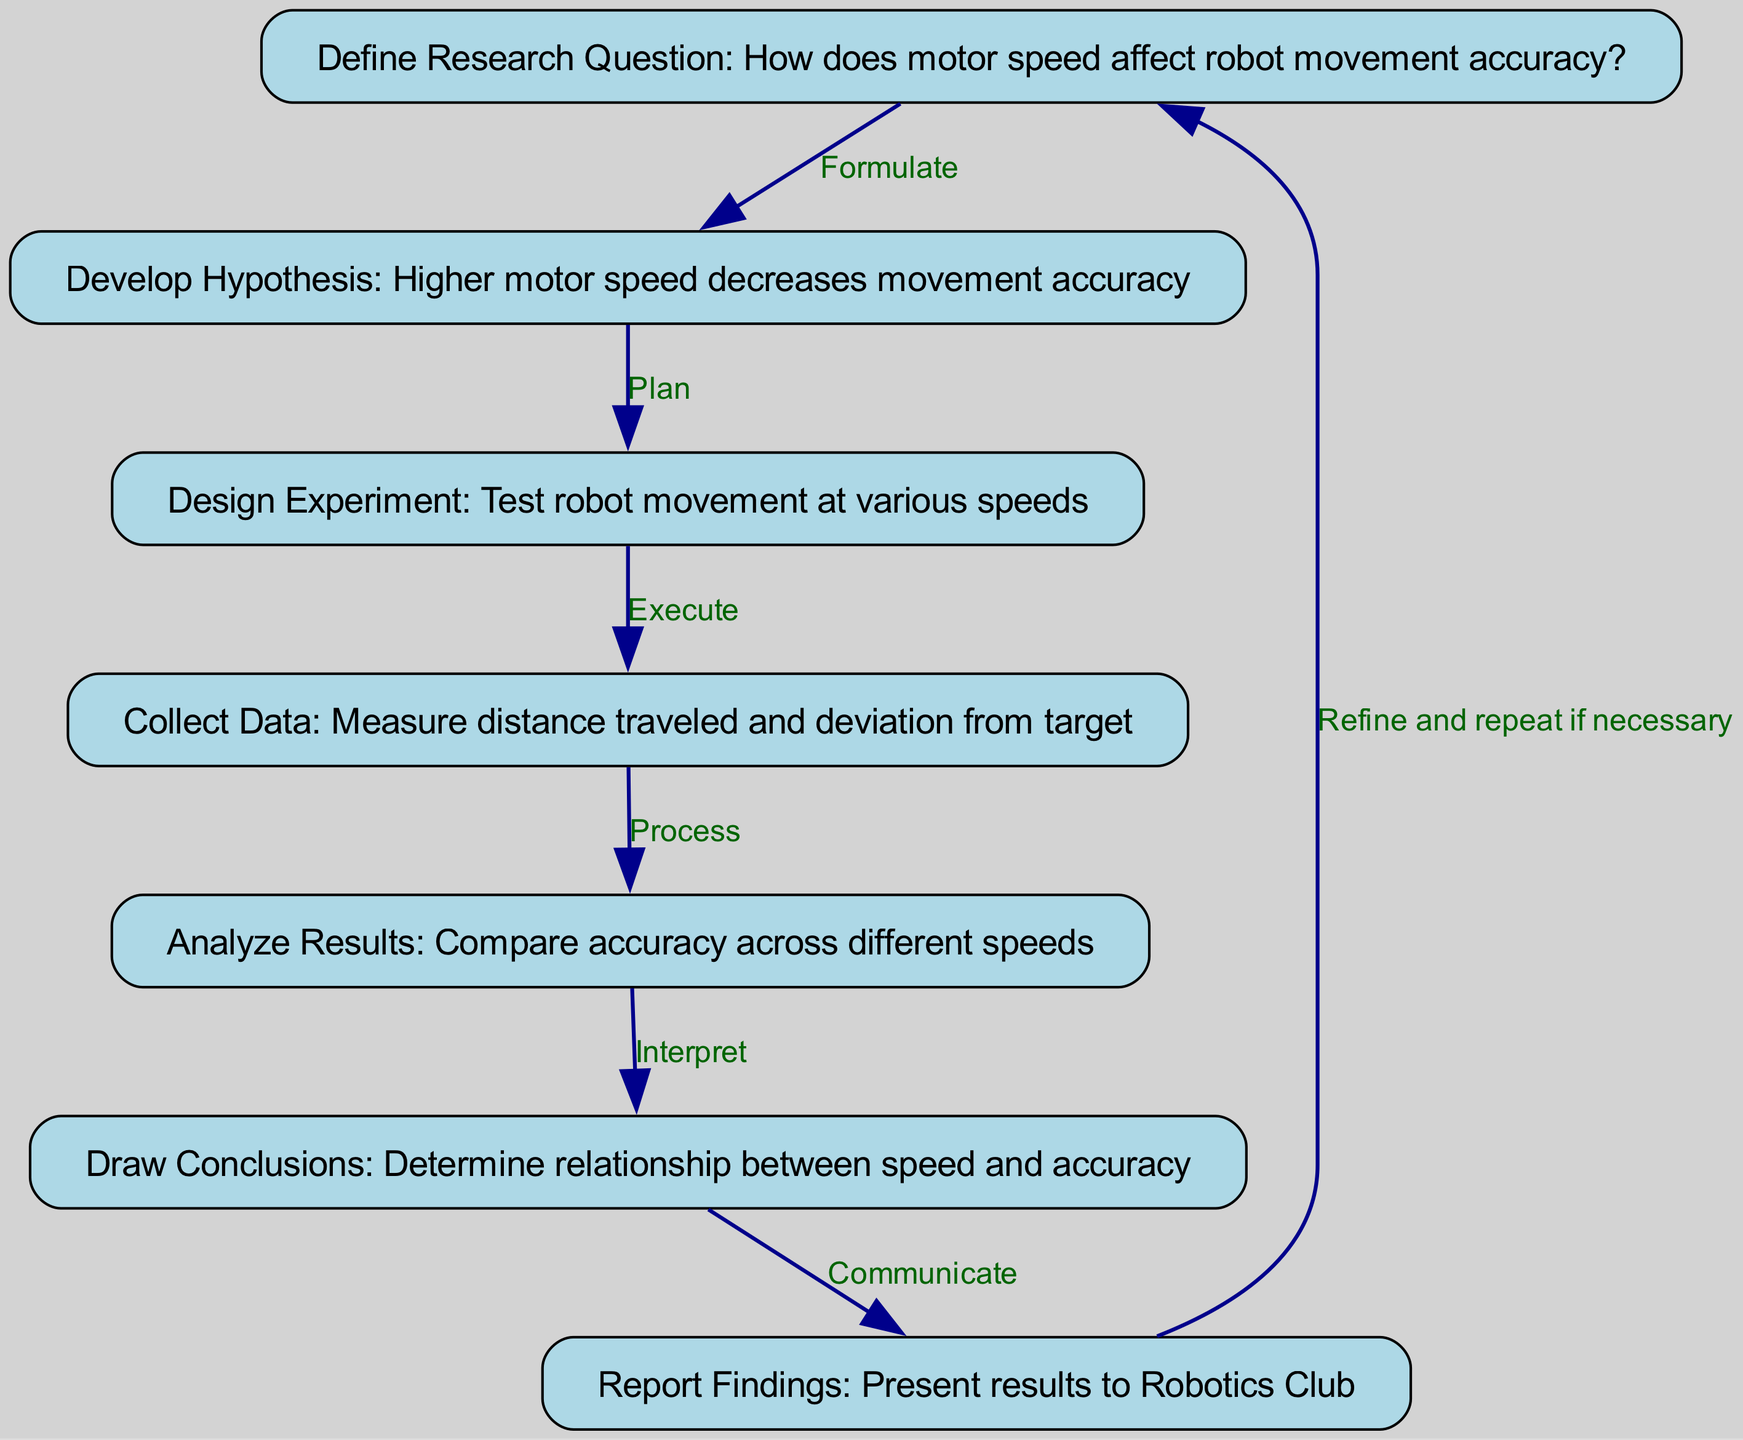What is the first step in the flowchart? The first step in the flowchart is labeled as "1" and states "Define Research Question: How does motor speed affect robot movement accuracy?"
Answer: Define Research Question: How does motor speed affect robot movement accuracy? How many nodes are present in the diagram? By counting each step in the flowchart, there are a total of 7 nodes representing different steps in the scientific method.
Answer: 7 What is the last step before reporting findings? The last step before reporting findings is step 6, which is "Draw Conclusions: Determine relationship between speed and accuracy."
Answer: Draw Conclusions: Determine relationship between speed and accuracy What relationship exists between "Analyze Results" and "Collect Data"? The relationship between "Analyze Results" and "Collect Data" is a sequential process where data collected is subsequently analyzed, indicated by the edge that connects the two nodes in the flowchart.
Answer: Analyze Results ← Collect Data What action is taken after formulating a hypothesis? After formulating a hypothesis, the next action is to "Design Experiment: Test robot movement at various speeds," which is shown as a direct connection from node 2 to node 3 in the flowchart.
Answer: Design Experiment: Test robot movement at various speeds What does the flowchart suggest should be done if conclusions require refinement? The flowchart indicates that if conclusions require refinement, one should "Refine and repeat if necessary," which loops back to the first step in the process.
Answer: Refine and repeat if necessary What step follows after data collection? After data collection, the next step in the flowchart is "Analyze Results: Compare accuracy across different speeds," which connects directly from data collection to result analysis.
Answer: Analyze Results: Compare accuracy across different speeds 